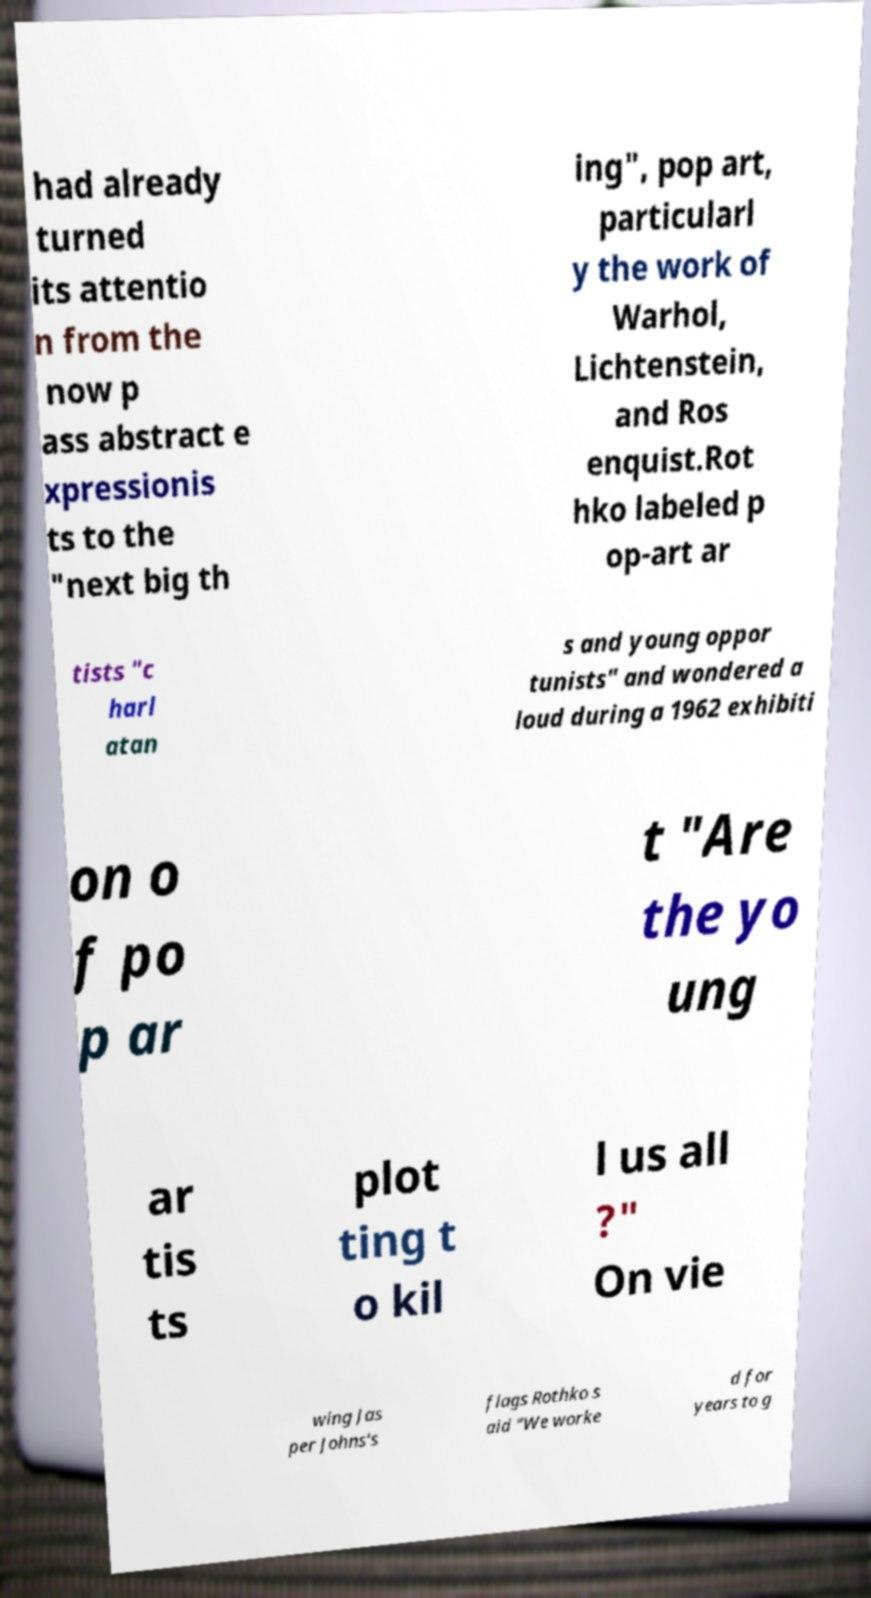Can you read and provide the text displayed in the image?This photo seems to have some interesting text. Can you extract and type it out for me? had already turned its attentio n from the now p ass abstract e xpressionis ts to the "next big th ing", pop art, particularl y the work of Warhol, Lichtenstein, and Ros enquist.Rot hko labeled p op-art ar tists "c harl atan s and young oppor tunists" and wondered a loud during a 1962 exhibiti on o f po p ar t "Are the yo ung ar tis ts plot ting t o kil l us all ?" On vie wing Jas per Johns's flags Rothko s aid "We worke d for years to g 